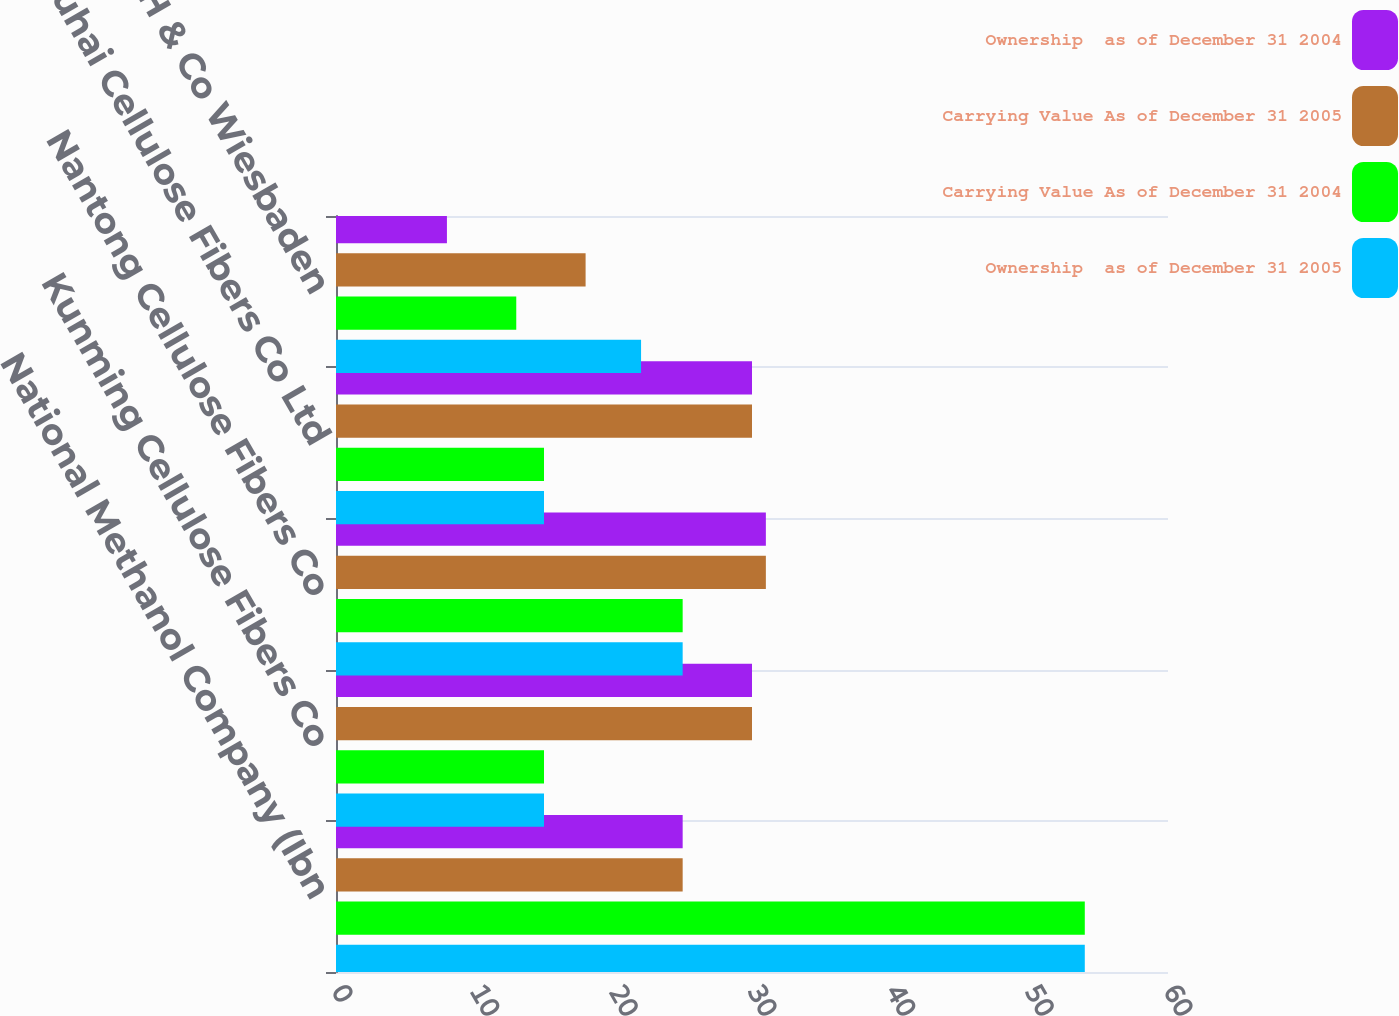Convert chart. <chart><loc_0><loc_0><loc_500><loc_500><stacked_bar_chart><ecel><fcel>National Methanol Company (Ibn<fcel>Kunming Cellulose Fibers Co<fcel>Nantong Cellulose Fibers Co<fcel>Zhuhai Cellulose Fibers Co Ltd<fcel>InfraServ GmbH & Co Wiesbaden<nl><fcel>Ownership  as of December 31 2004<fcel>25<fcel>30<fcel>31<fcel>30<fcel>8<nl><fcel>Carrying Value As of December 31 2005<fcel>25<fcel>30<fcel>31<fcel>30<fcel>18<nl><fcel>Carrying Value As of December 31 2004<fcel>54<fcel>15<fcel>25<fcel>15<fcel>13<nl><fcel>Ownership  as of December 31 2005<fcel>54<fcel>15<fcel>25<fcel>15<fcel>22<nl></chart> 